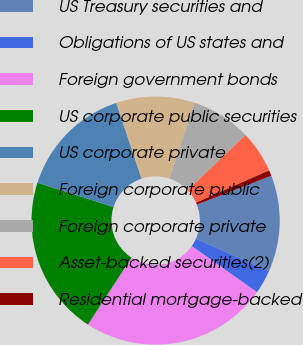<chart> <loc_0><loc_0><loc_500><loc_500><pie_chart><fcel>US Treasury securities and<fcel>Obligations of US states and<fcel>Foreign government bonds<fcel>US corporate public securities<fcel>US corporate private<fcel>Foreign corporate public<fcel>Foreign corporate private<fcel>Asset-backed securities(2)<fcel>Residential mortgage-backed<nl><fcel>12.57%<fcel>3.11%<fcel>24.39%<fcel>20.75%<fcel>14.93%<fcel>10.2%<fcel>7.84%<fcel>5.47%<fcel>0.74%<nl></chart> 